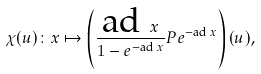<formula> <loc_0><loc_0><loc_500><loc_500>\chi ( u ) \colon x \mapsto \left ( \frac { { \text {ad } x } } { 1 - e ^ { - { \text {ad } x } } } P e ^ { - { \text {ad } x } } \right ) ( u ) ,</formula> 